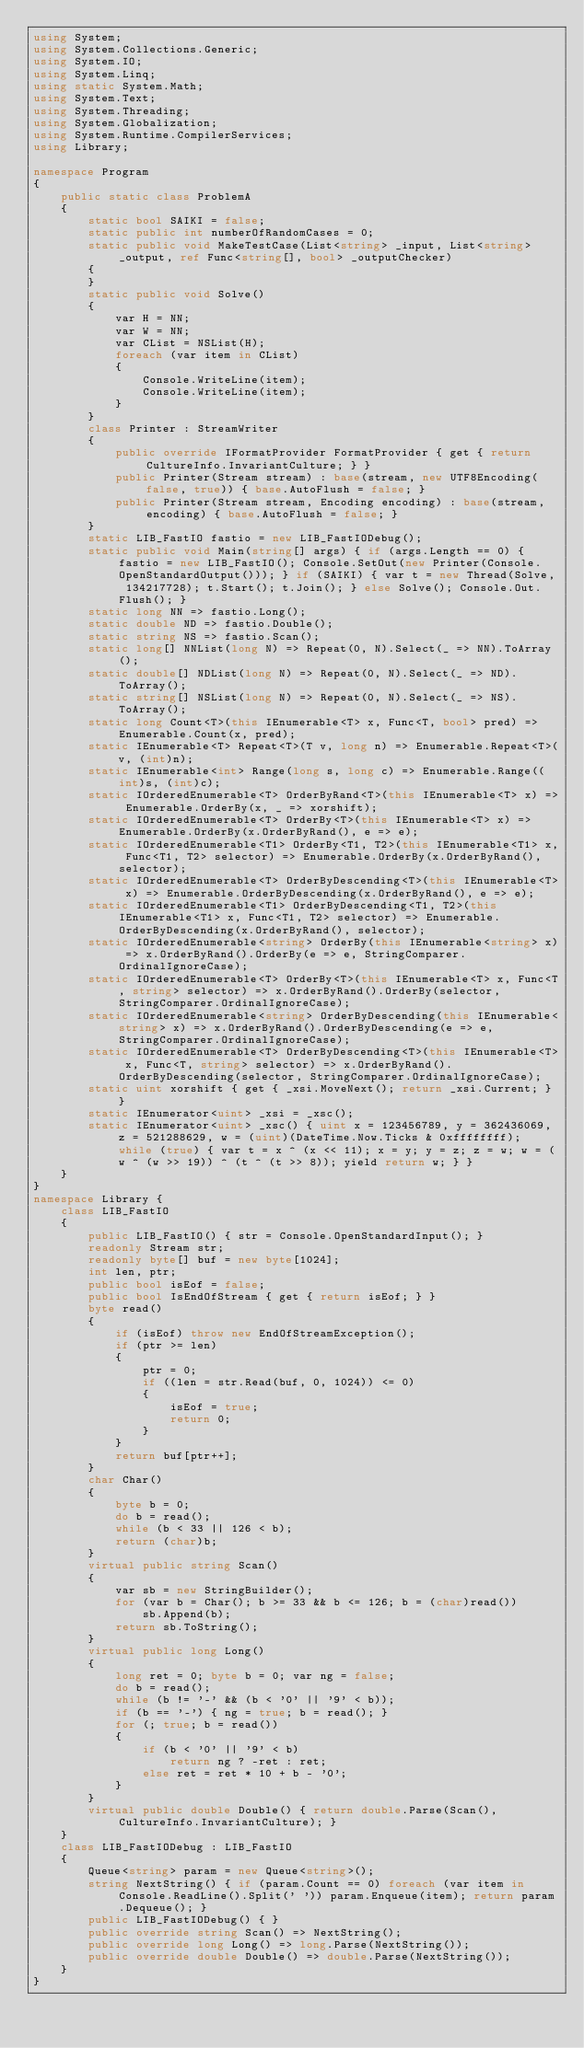Convert code to text. <code><loc_0><loc_0><loc_500><loc_500><_C#_>using System;
using System.Collections.Generic;
using System.IO;
using System.Linq;
using static System.Math;
using System.Text;
using System.Threading;
using System.Globalization;
using System.Runtime.CompilerServices;
using Library;

namespace Program
{
    public static class ProblemA
    {
        static bool SAIKI = false;
        static public int numberOfRandomCases = 0;
        static public void MakeTestCase(List<string> _input, List<string> _output, ref Func<string[], bool> _outputChecker)
        {
        }
        static public void Solve()
        {
            var H = NN;
            var W = NN;
            var CList = NSList(H);
            foreach (var item in CList)
            {
                Console.WriteLine(item);
                Console.WriteLine(item);
            }
        }
        class Printer : StreamWriter
        {
            public override IFormatProvider FormatProvider { get { return CultureInfo.InvariantCulture; } }
            public Printer(Stream stream) : base(stream, new UTF8Encoding(false, true)) { base.AutoFlush = false; }
            public Printer(Stream stream, Encoding encoding) : base(stream, encoding) { base.AutoFlush = false; }
        }
        static LIB_FastIO fastio = new LIB_FastIODebug();
        static public void Main(string[] args) { if (args.Length == 0) { fastio = new LIB_FastIO(); Console.SetOut(new Printer(Console.OpenStandardOutput())); } if (SAIKI) { var t = new Thread(Solve, 134217728); t.Start(); t.Join(); } else Solve(); Console.Out.Flush(); }
        static long NN => fastio.Long();
        static double ND => fastio.Double();
        static string NS => fastio.Scan();
        static long[] NNList(long N) => Repeat(0, N).Select(_ => NN).ToArray();
        static double[] NDList(long N) => Repeat(0, N).Select(_ => ND).ToArray();
        static string[] NSList(long N) => Repeat(0, N).Select(_ => NS).ToArray();
        static long Count<T>(this IEnumerable<T> x, Func<T, bool> pred) => Enumerable.Count(x, pred);
        static IEnumerable<T> Repeat<T>(T v, long n) => Enumerable.Repeat<T>(v, (int)n);
        static IEnumerable<int> Range(long s, long c) => Enumerable.Range((int)s, (int)c);
        static IOrderedEnumerable<T> OrderByRand<T>(this IEnumerable<T> x) => Enumerable.OrderBy(x, _ => xorshift);
        static IOrderedEnumerable<T> OrderBy<T>(this IEnumerable<T> x) => Enumerable.OrderBy(x.OrderByRand(), e => e);
        static IOrderedEnumerable<T1> OrderBy<T1, T2>(this IEnumerable<T1> x, Func<T1, T2> selector) => Enumerable.OrderBy(x.OrderByRand(), selector);
        static IOrderedEnumerable<T> OrderByDescending<T>(this IEnumerable<T> x) => Enumerable.OrderByDescending(x.OrderByRand(), e => e);
        static IOrderedEnumerable<T1> OrderByDescending<T1, T2>(this IEnumerable<T1> x, Func<T1, T2> selector) => Enumerable.OrderByDescending(x.OrderByRand(), selector);
        static IOrderedEnumerable<string> OrderBy(this IEnumerable<string> x) => x.OrderByRand().OrderBy(e => e, StringComparer.OrdinalIgnoreCase);
        static IOrderedEnumerable<T> OrderBy<T>(this IEnumerable<T> x, Func<T, string> selector) => x.OrderByRand().OrderBy(selector, StringComparer.OrdinalIgnoreCase);
        static IOrderedEnumerable<string> OrderByDescending(this IEnumerable<string> x) => x.OrderByRand().OrderByDescending(e => e, StringComparer.OrdinalIgnoreCase);
        static IOrderedEnumerable<T> OrderByDescending<T>(this IEnumerable<T> x, Func<T, string> selector) => x.OrderByRand().OrderByDescending(selector, StringComparer.OrdinalIgnoreCase);
        static uint xorshift { get { _xsi.MoveNext(); return _xsi.Current; } }
        static IEnumerator<uint> _xsi = _xsc();
        static IEnumerator<uint> _xsc() { uint x = 123456789, y = 362436069, z = 521288629, w = (uint)(DateTime.Now.Ticks & 0xffffffff); while (true) { var t = x ^ (x << 11); x = y; y = z; z = w; w = (w ^ (w >> 19)) ^ (t ^ (t >> 8)); yield return w; } }
    }
}
namespace Library {
    class LIB_FastIO
    {
        public LIB_FastIO() { str = Console.OpenStandardInput(); }
        readonly Stream str;
        readonly byte[] buf = new byte[1024];
        int len, ptr;
        public bool isEof = false;
        public bool IsEndOfStream { get { return isEof; } }
        byte read()
        {
            if (isEof) throw new EndOfStreamException();
            if (ptr >= len)
            {
                ptr = 0;
                if ((len = str.Read(buf, 0, 1024)) <= 0)
                {
                    isEof = true;
                    return 0;
                }
            }
            return buf[ptr++];
        }
        char Char()
        {
            byte b = 0;
            do b = read();
            while (b < 33 || 126 < b);
            return (char)b;
        }
        virtual public string Scan()
        {
            var sb = new StringBuilder();
            for (var b = Char(); b >= 33 && b <= 126; b = (char)read())
                sb.Append(b);
            return sb.ToString();
        }
        virtual public long Long()
        {
            long ret = 0; byte b = 0; var ng = false;
            do b = read();
            while (b != '-' && (b < '0' || '9' < b));
            if (b == '-') { ng = true; b = read(); }
            for (; true; b = read())
            {
                if (b < '0' || '9' < b)
                    return ng ? -ret : ret;
                else ret = ret * 10 + b - '0';
            }
        }
        virtual public double Double() { return double.Parse(Scan(), CultureInfo.InvariantCulture); }
    }
    class LIB_FastIODebug : LIB_FastIO
    {
        Queue<string> param = new Queue<string>();
        string NextString() { if (param.Count == 0) foreach (var item in Console.ReadLine().Split(' ')) param.Enqueue(item); return param.Dequeue(); }
        public LIB_FastIODebug() { }
        public override string Scan() => NextString();
        public override long Long() => long.Parse(NextString());
        public override double Double() => double.Parse(NextString());
    }
}
</code> 